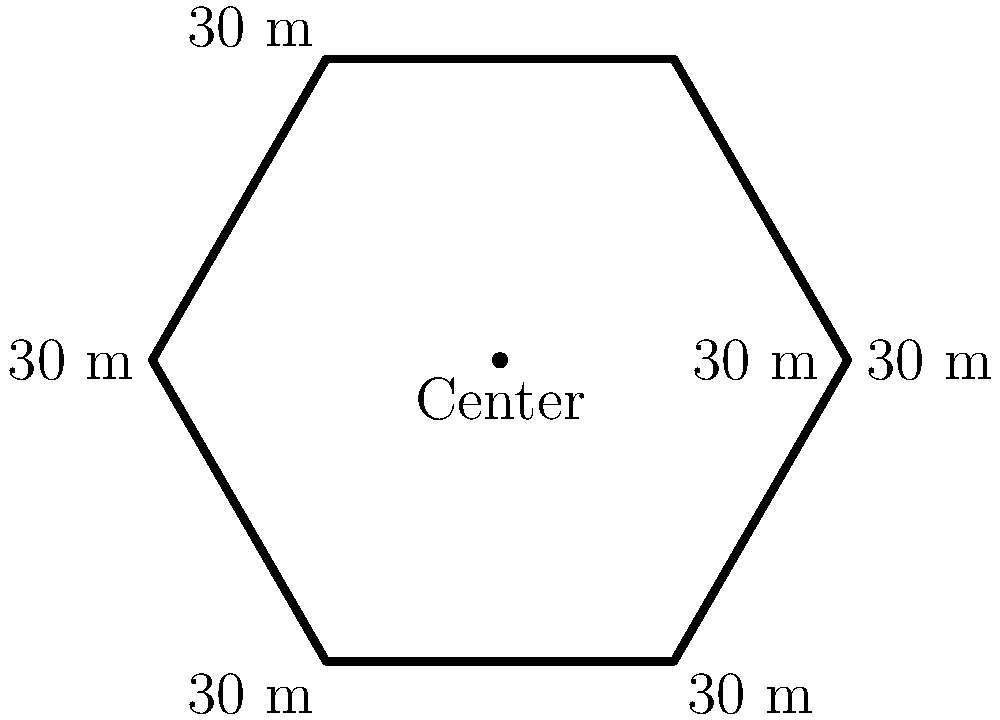In your latest thriller, the protagonist is trapped in a hexagonal garden maze during the climactic chase scene. Each side of the hexagon measures 30 meters. What is the perimeter of this suspenseful setting? To calculate the perimeter of the hexagonal garden maze, we need to follow these steps:

1. Identify the shape: We have a regular hexagon, which means all sides are equal in length.

2. Note the length of one side: Each side of the hexagon measures 30 meters.

3. Recall the formula for the perimeter of a regular polygon: 
   Perimeter = number of sides × length of one side

4. For a hexagon, the number of sides is 6.

5. Apply the formula:
   Perimeter = 6 × 30 meters

6. Calculate:
   Perimeter = 180 meters

Therefore, the perimeter of the hexagonal garden maze in your thriller's climactic chase scene is 180 meters.
Answer: 180 meters 